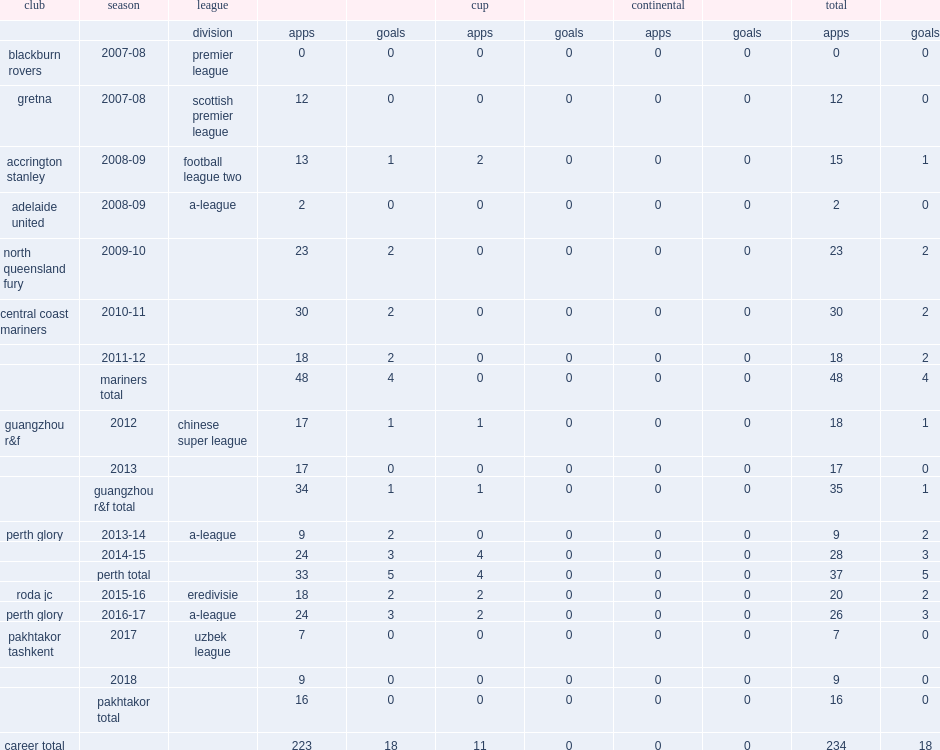In 2017, which club did griffiths join in the uzbek league? Pakhtakor tashkent. 